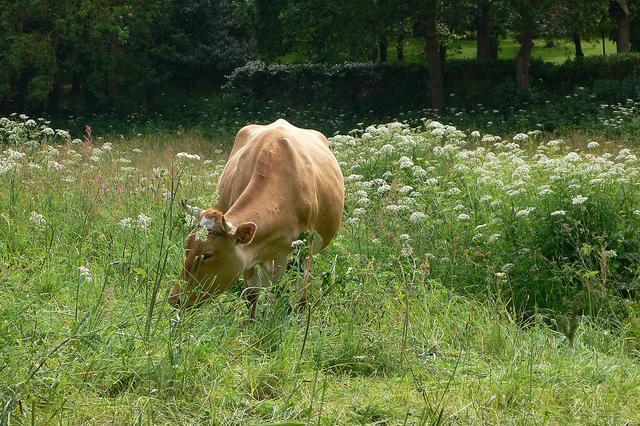How many cows are in the photo?
Give a very brief answer. 1. How many people are wearing helmet?
Give a very brief answer. 0. 